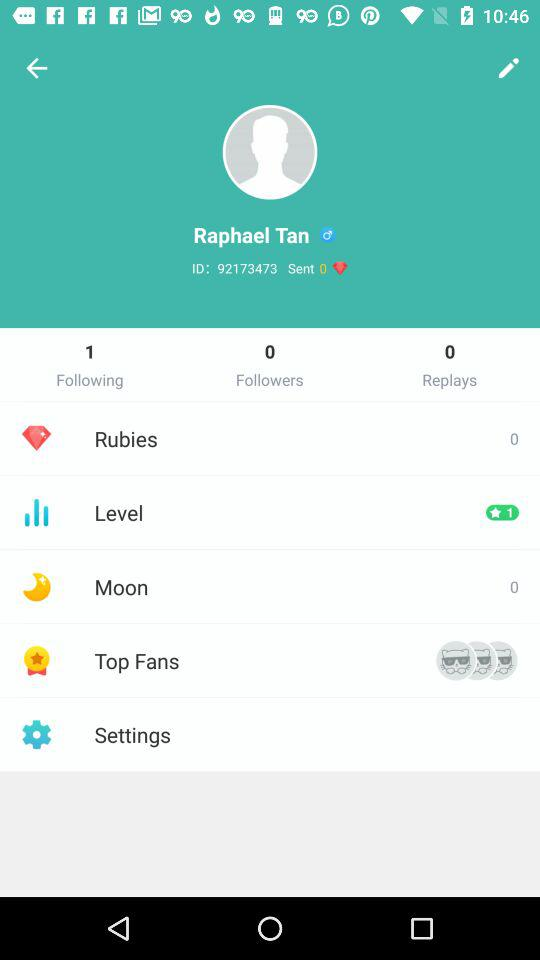How many people does the user follow? The user follows 1 person. 